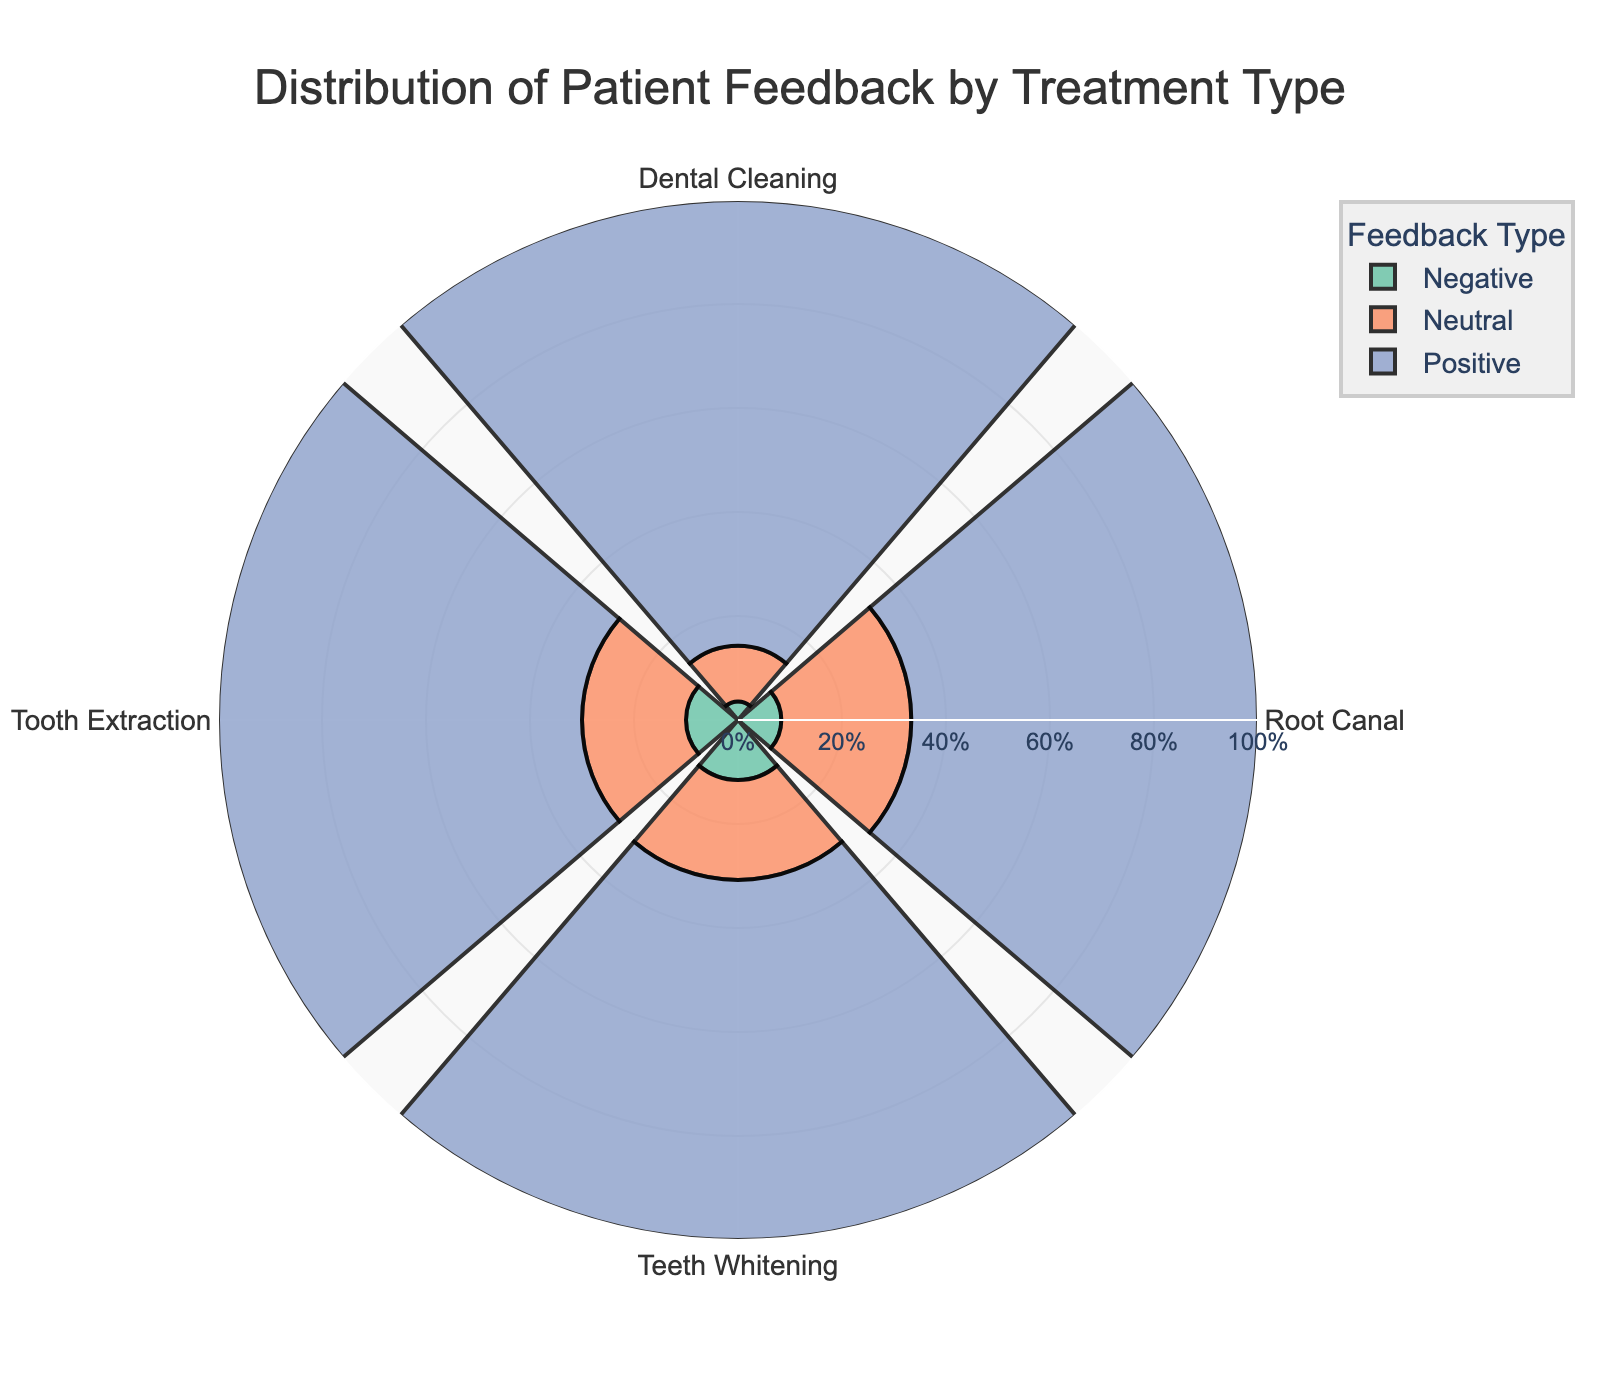What is the title of the figure? Refer to the top of the chart where the textual information is placed. The title is prominently displayed in a larger font size.
Answer: Distribution of Patient Feedback by Treatment Type Which treatment type received the highest percentage of positive feedback? Look at the section labeled "Positive" for each treatment type. Compare the heights of these sections to find the tallest one.
Answer: Dental Cleaning What is the percentage of neutral feedback for Teeth Whitening? Identify the Teeth Whitening treatment type and then find the segment colored for neutral feedback. The percentage value within this segment indicates the answer.
Answer: 20.8% Which feedback type is the least represented in Tooth Extraction? Examine the Tooth Extraction segments, then determine which type (Positive, Neutral, or Negative) has the smallest portion.
Answer: Negative What is the difference in the percentage of positive feedback between Root Canal and Tooth Extraction? Find the positive feedback percentages for Root Canal and Tooth Extraction, then subtract the smaller percentage from the larger one.
Answer: 20% How do the percentages of negative feedback for Root Canal and Teeth Whitening compare? Locate the negative feedback segments for both Root Canal and Teeth Whitening, then compare the percentages to each other to determine the relationship.
Answer: Negative feedback is the same for both Which treatment type has the highest overall percentage of neutral feedback? Look through each treatment type's section for neutral feedback and find the one with the highest percentage.
Answer: Root Canal What is the total percentage of positive feedback for all treatment types combined? Add the positive feedback percentages from each treatment type together. These percentages are: 81.6% (Dental Cleaning), 66.7% (Root Canal), 68.7% (Teeth Whitening), and 70% (Tooth Extraction).
Answer: 287% If you were to average the percentage of negative feedback across all treatment types, what would it be? Sum the negative feedback percentages for all treatment types, then divide by the number of treatment types (4). The values are: 3.3% (Dental Cleaning), 8.3% (Root Canal), 11.5% (Teeth Whitening), and 10% (Tooth Extraction).
Answer: 8.25% 